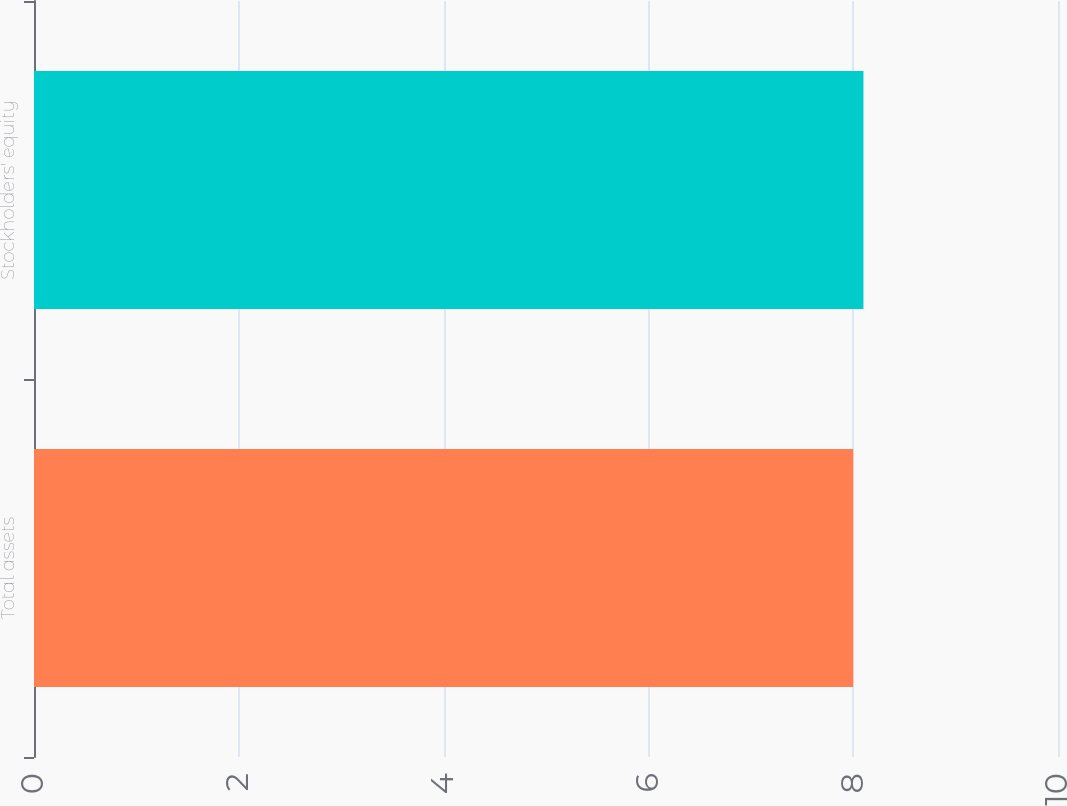Convert chart. <chart><loc_0><loc_0><loc_500><loc_500><bar_chart><fcel>Total assets<fcel>Stockholders' equity<nl><fcel>8<fcel>8.1<nl></chart> 